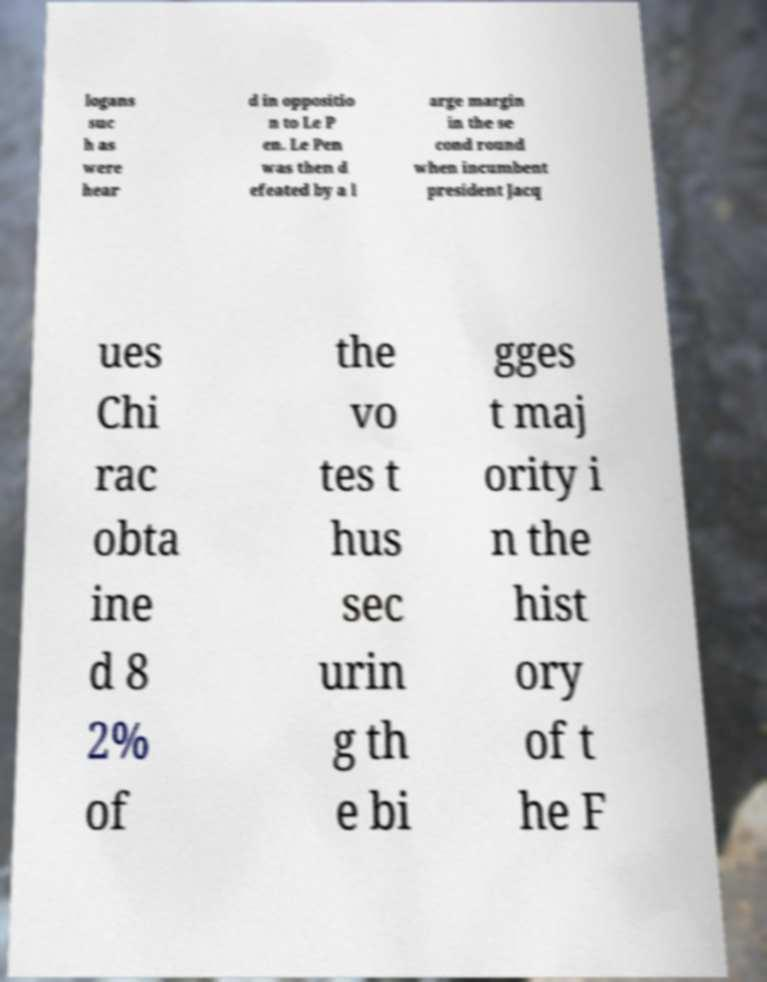Can you read and provide the text displayed in the image?This photo seems to have some interesting text. Can you extract and type it out for me? logans suc h as were hear d in oppositio n to Le P en. Le Pen was then d efeated by a l arge margin in the se cond round when incumbent president Jacq ues Chi rac obta ine d 8 2% of the vo tes t hus sec urin g th e bi gges t maj ority i n the hist ory of t he F 